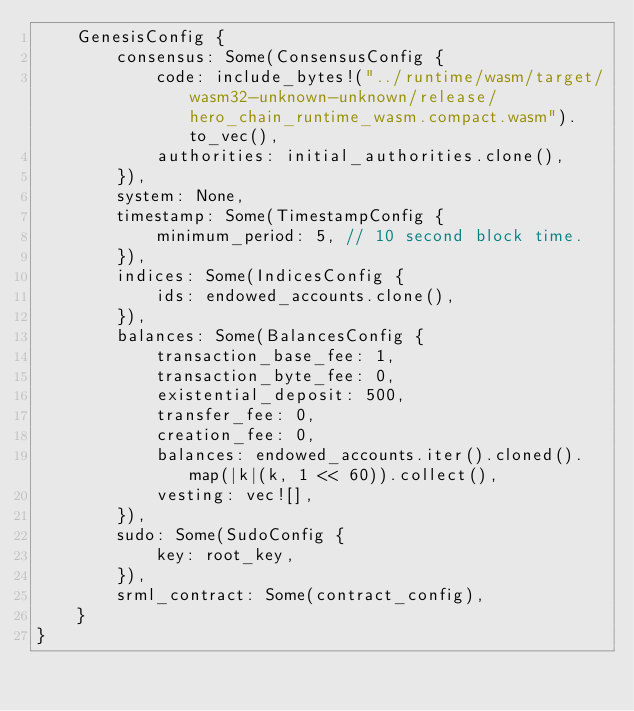Convert code to text. <code><loc_0><loc_0><loc_500><loc_500><_Rust_>	GenesisConfig {
		consensus: Some(ConsensusConfig {
			code: include_bytes!("../runtime/wasm/target/wasm32-unknown-unknown/release/hero_chain_runtime_wasm.compact.wasm").to_vec(),
			authorities: initial_authorities.clone(),
		}),
		system: None,
		timestamp: Some(TimestampConfig {
			minimum_period: 5, // 10 second block time.
		}),
		indices: Some(IndicesConfig {
			ids: endowed_accounts.clone(),
		}),
		balances: Some(BalancesConfig {
			transaction_base_fee: 1,
			transaction_byte_fee: 0,
			existential_deposit: 500,
			transfer_fee: 0,
			creation_fee: 0,
			balances: endowed_accounts.iter().cloned().map(|k|(k, 1 << 60)).collect(),
			vesting: vec![],
		}),
		sudo: Some(SudoConfig {
			key: root_key,
		}),
		srml_contract: Some(contract_config),
	}
}
</code> 